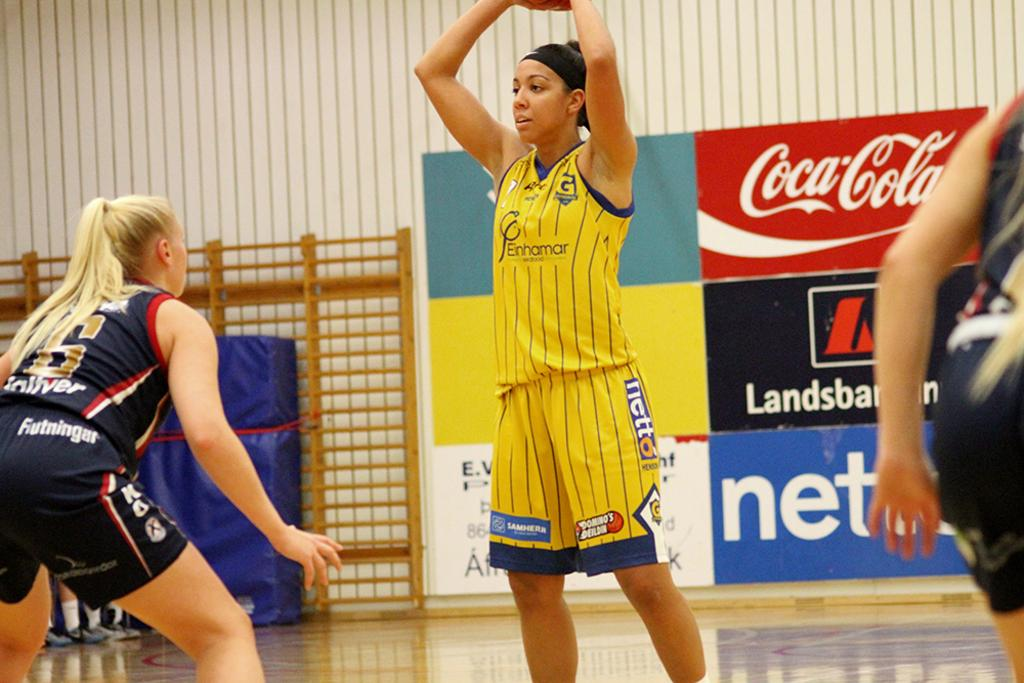<image>
Summarize the visual content of the image. a player with the ball and a coca cola ad behind them 